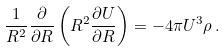Convert formula to latex. <formula><loc_0><loc_0><loc_500><loc_500>\frac { 1 } { R ^ { 2 } } \frac { \partial } { \partial R } \left ( R ^ { 2 } \frac { \partial U } { \partial R } \right ) = - 4 \pi U ^ { 3 } \rho \, .</formula> 